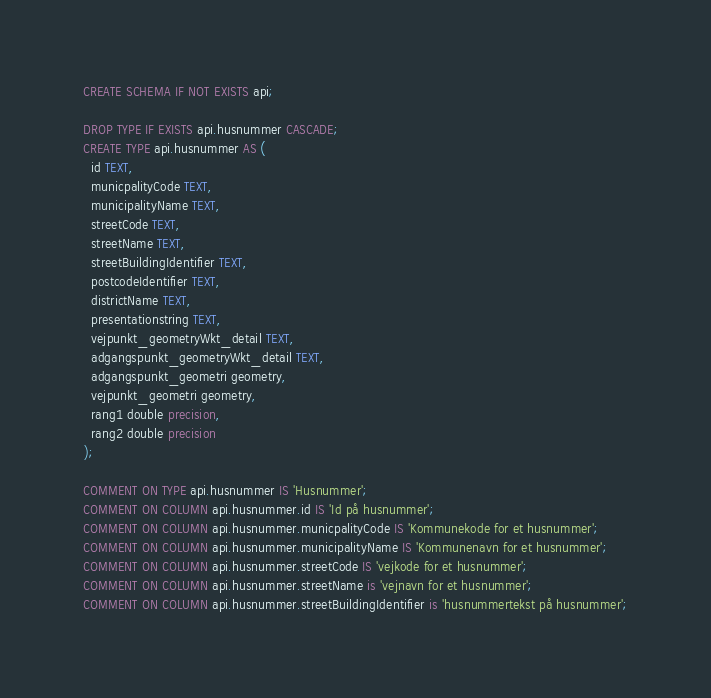<code> <loc_0><loc_0><loc_500><loc_500><_SQL_>CREATE SCHEMA IF NOT EXISTS api;

DROP TYPE IF EXISTS api.husnummer CASCADE;
CREATE TYPE api.husnummer AS (
  id TEXT,
  municpalityCode TEXT,
  municipalityName TEXT,
  streetCode TEXT,
  streetName TEXT,
  streetBuildingIdentifier TEXT,
  postcodeIdentifier TEXT,
  districtName TEXT,
  presentationstring TEXT,
  vejpunkt_geometryWkt_detail TEXT,
  adgangspunkt_geometryWkt_detail TEXT,
  adgangspunkt_geometri geometry,
  vejpunkt_geometri geometry,
  rang1 double precision,
  rang2 double precision
);  

COMMENT ON TYPE api.husnummer IS 'Husnummer';
COMMENT ON COLUMN api.husnummer.id IS 'Id på husnummer';
COMMENT ON COLUMN api.husnummer.municpalityCode IS 'Kommunekode for et husnummer';
COMMENT ON COLUMN api.husnummer.municipalityName IS 'Kommunenavn for et husnummer';
COMMENT ON COLUMN api.husnummer.streetCode IS 'vejkode for et husnummer';
COMMENT ON COLUMN api.husnummer.streetName is 'vejnavn for et husnummer';
COMMENT ON COLUMN api.husnummer.streetBuildingIdentifier is 'husnummertekst på husnummer';</code> 